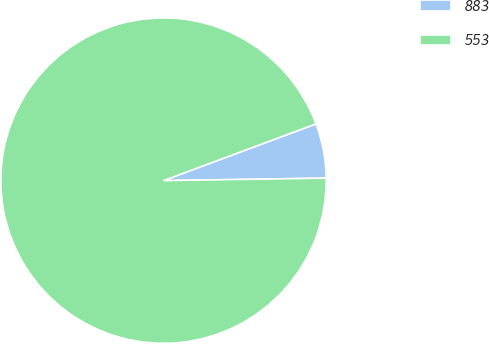Convert chart to OTSL. <chart><loc_0><loc_0><loc_500><loc_500><pie_chart><fcel>883<fcel>553<nl><fcel>5.43%<fcel>94.57%<nl></chart> 